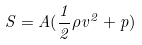Convert formula to latex. <formula><loc_0><loc_0><loc_500><loc_500>S = A ( \frac { 1 } { 2 } \rho v ^ { 2 } + p )</formula> 